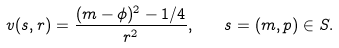<formula> <loc_0><loc_0><loc_500><loc_500>v ( s , r ) = \frac { ( m - \phi ) ^ { 2 } - 1 / 4 } { r ^ { 2 } } , \quad s = ( m , p ) \in S .</formula> 